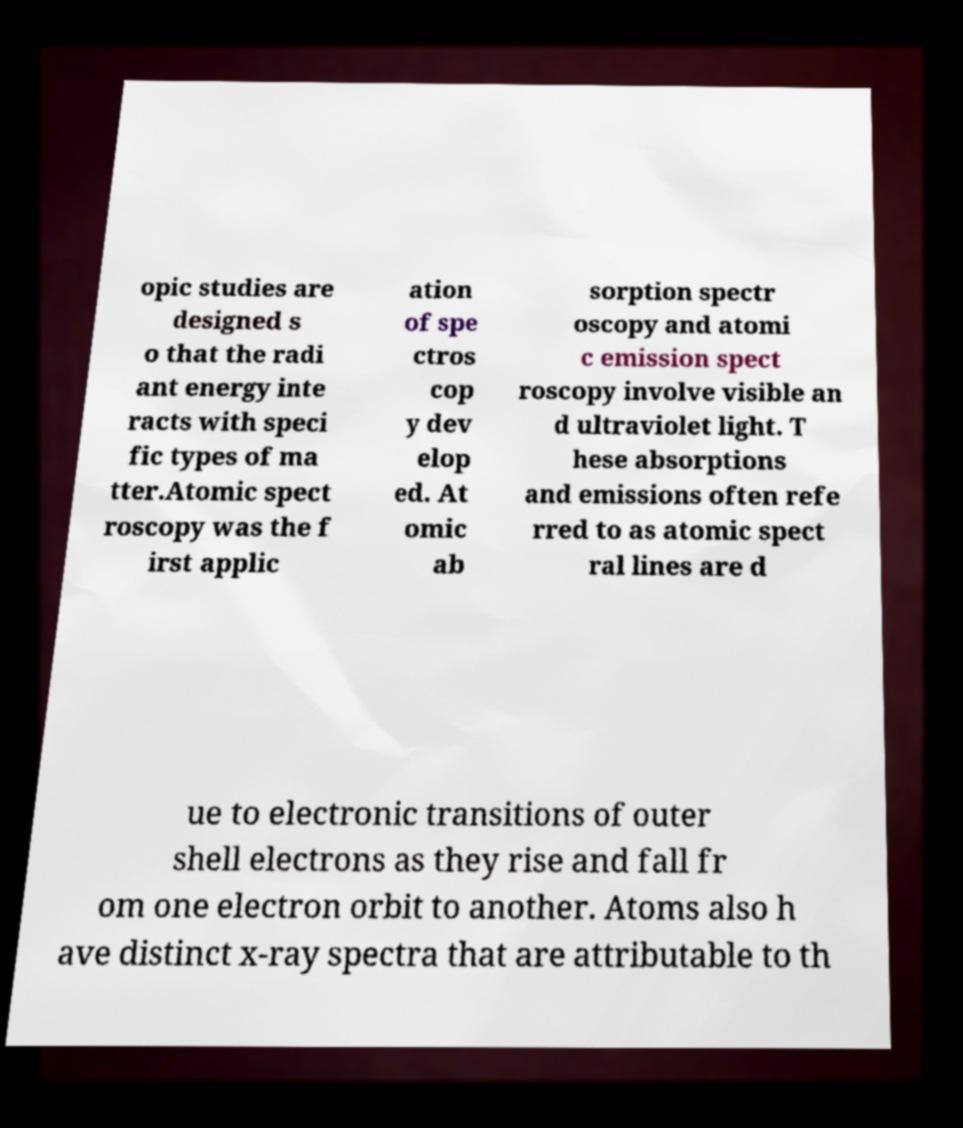Please read and relay the text visible in this image. What does it say? opic studies are designed s o that the radi ant energy inte racts with speci fic types of ma tter.Atomic spect roscopy was the f irst applic ation of spe ctros cop y dev elop ed. At omic ab sorption spectr oscopy and atomi c emission spect roscopy involve visible an d ultraviolet light. T hese absorptions and emissions often refe rred to as atomic spect ral lines are d ue to electronic transitions of outer shell electrons as they rise and fall fr om one electron orbit to another. Atoms also h ave distinct x-ray spectra that are attributable to th 